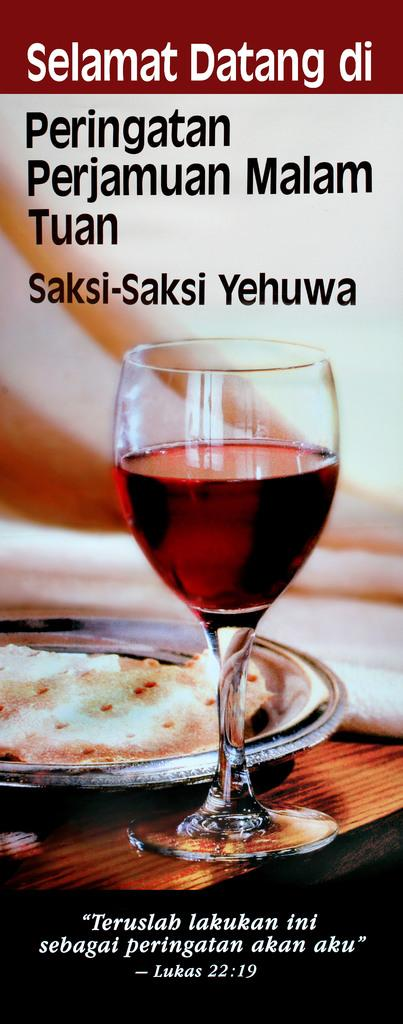What is featured on the poster in the image? The poster contains an image of a glass and a plate. Can you describe the images on the poster? The poster features an image of a glass and a plate. Is there a woman ringing a bell in the image? There is no woman or bell present in the image; the poster contains images of a glass and a plate. 